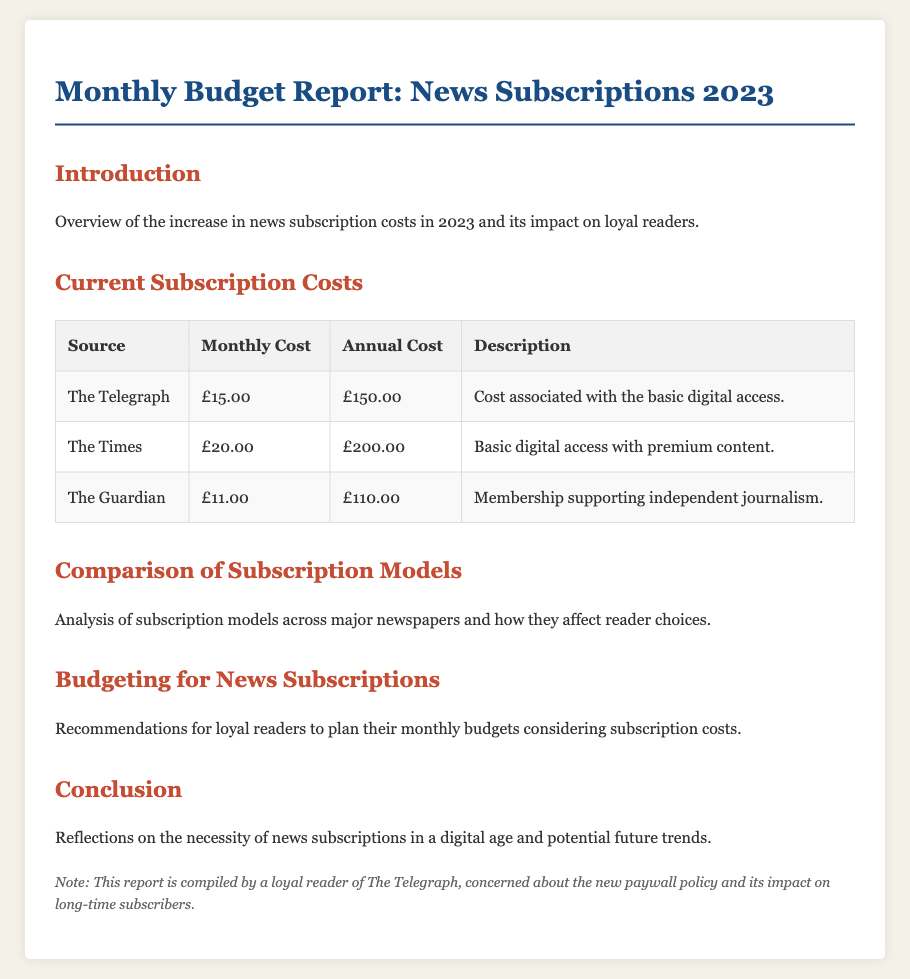What is the monthly cost for The Telegraph? The monthly cost for The Telegraph is detailed in the subscription table under "Monthly Cost."
Answer: £15.00 What is the annual cost for The Guardian? The annual cost for The Guardian is listed in the subscription table under "Annual Cost."
Answer: £110.00 How much does The Times charge monthly? The document specifies the monthly charge of The Times in the subscription section.
Answer: £20.00 Which subscription supports independent journalism? The description for The Guardian explicitly states its mission to support independent journalism.
Answer: The Guardian What is the total annual cost for The Telegraph and The Times? The total annual cost is the sum of both subscriptions from the "Annual Cost" row.
Answer: £350.00 What color is used for the title of the report? The color used for the title is defined in the HTML, under the "h1" style.
Answer: #1a4c84 How is the report concluded? The conclusion is summarized in the final section of the document that reflects on subscription necessity.
Answer: Potential future trends What is the purpose of the "Budgeting for News Subscriptions" section? This section is meant to provide recommendations for readers on how to manage subscription costs.
Answer: Recommendations for loyal readers 